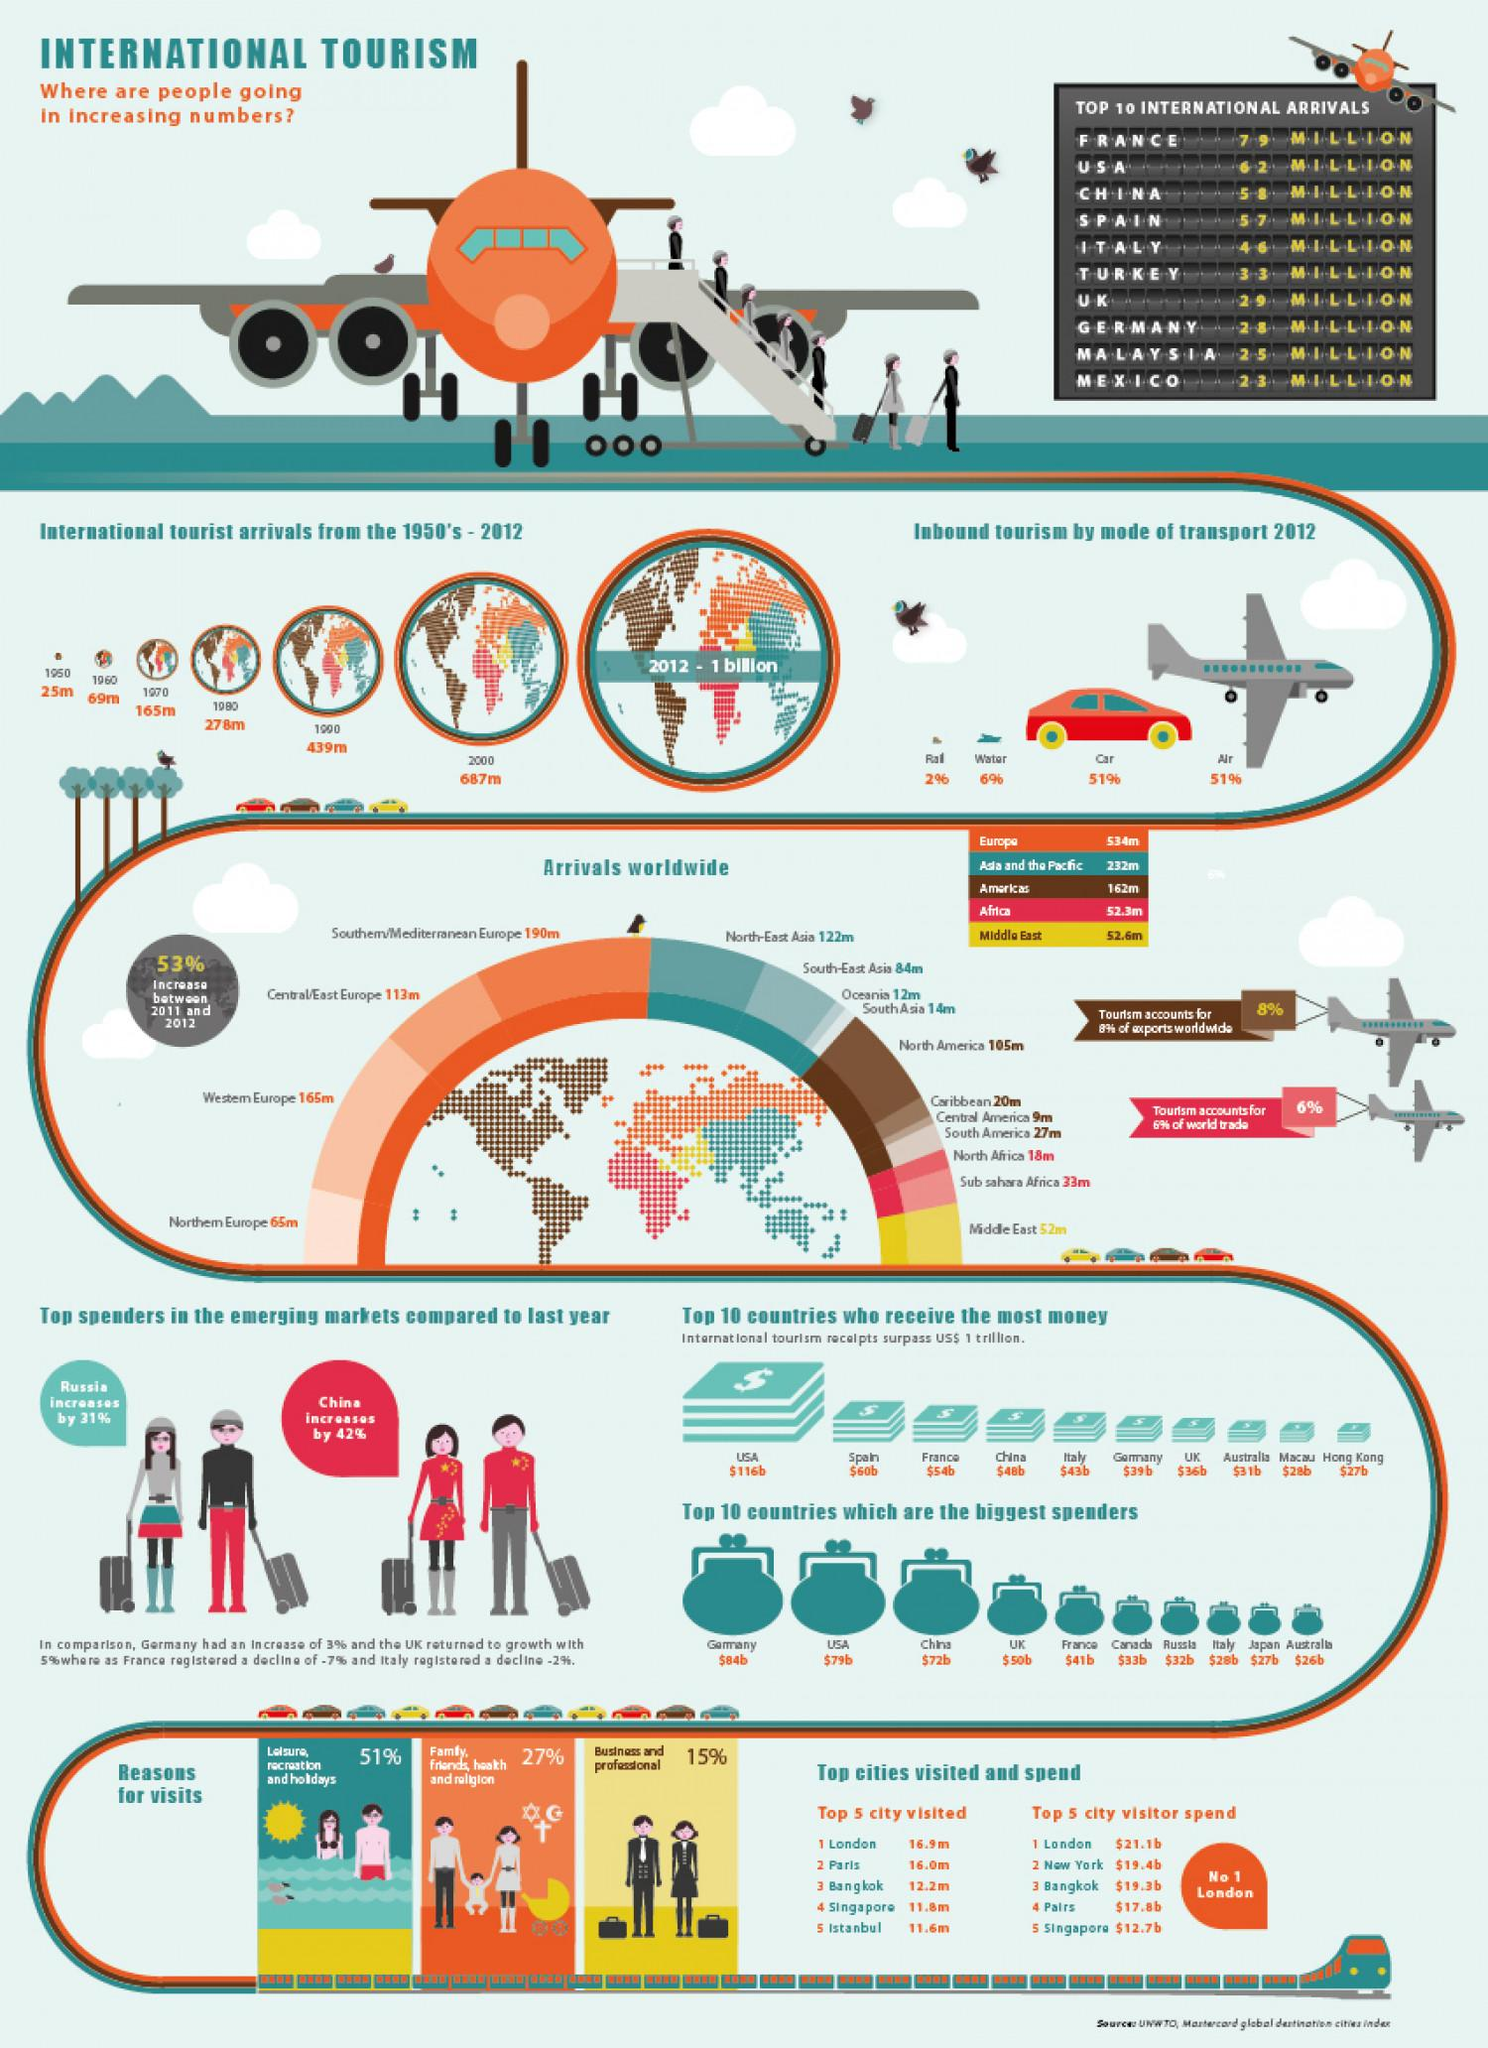Identify some key points in this picture. In 1950 and 1960, the combined number of international tourist arrivals was approximately 94 million. Inbound tourism in a particular region is primarily facilitated by car and water transport, with a combined percentage of 57%. The combined arrivals in South Asia and the Caribbean total 34 million. In 2020, the percentage of inbound tourism that was transported by air and rail was 53%. In 1970 and 1980, the combined number of international tourist arrivals was approximately 443 million. 